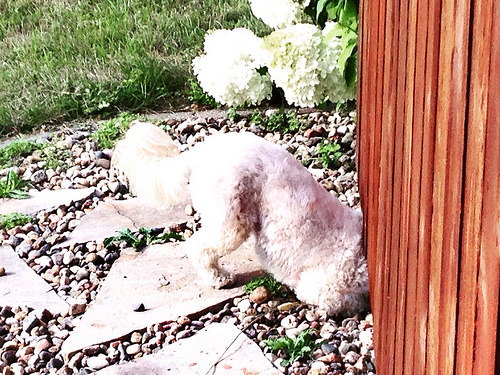<image>
Is the flower above the dog? No. The flower is not positioned above the dog. The vertical arrangement shows a different relationship. 